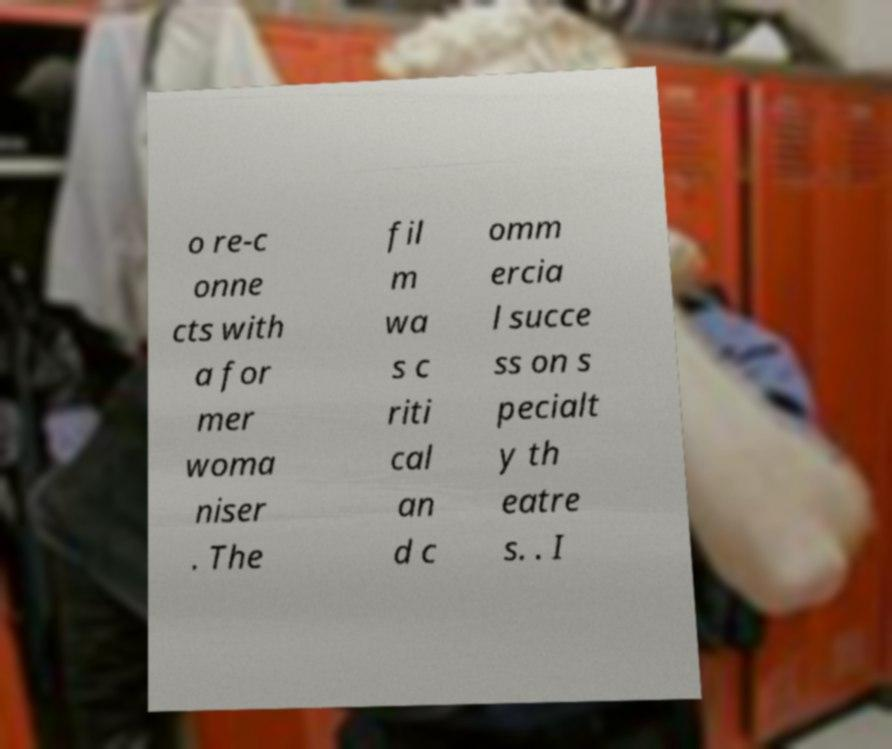Could you assist in decoding the text presented in this image and type it out clearly? o re-c onne cts with a for mer woma niser . The fil m wa s c riti cal an d c omm ercia l succe ss on s pecialt y th eatre s. . I 